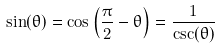Convert formula to latex. <formula><loc_0><loc_0><loc_500><loc_500>\sin ( \theta ) = \cos \left ( { \frac { \pi } { 2 } } - \theta \right ) = { \frac { 1 } { \csc ( \theta ) } }</formula> 